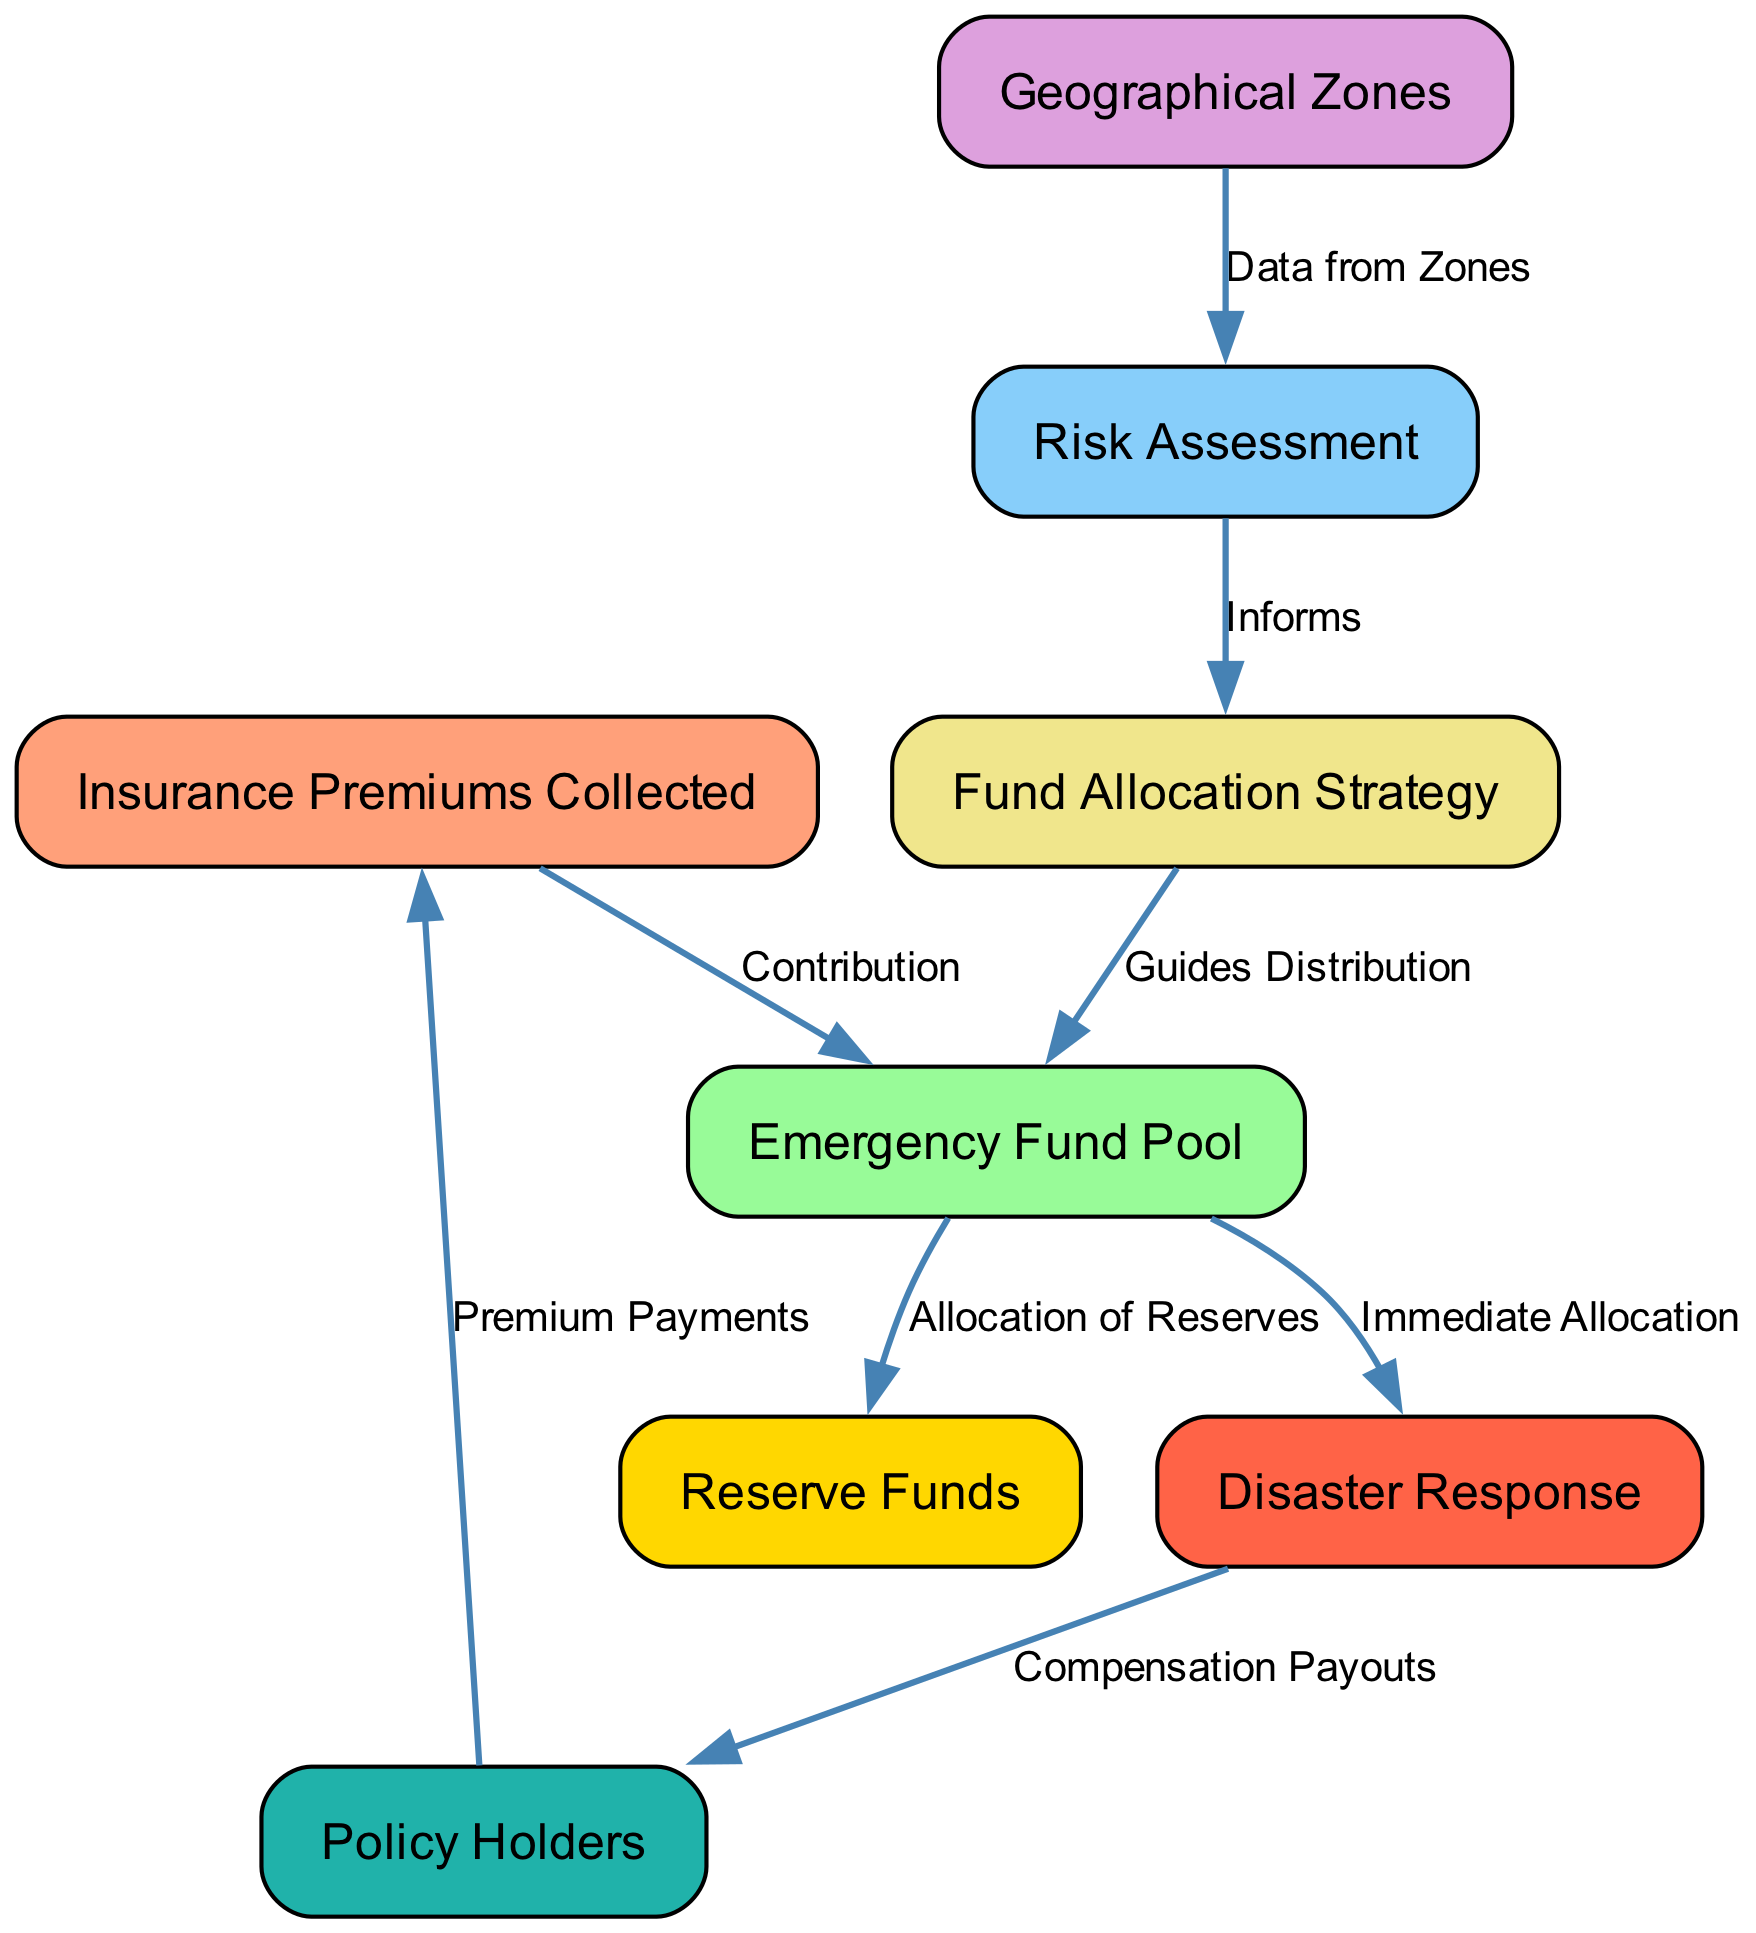What is the first node in the diagram? The first node is the starting point of the flow, which represents the collection of funds. According to the diagram, it is labeled "Insurance Premiums Collected."
Answer: Insurance Premiums Collected How many edges are there in the diagram? The edges in the diagram represent the relationships between the nodes. Counting them shows that there are a total of 8 edges connecting the different nodes.
Answer: 8 What node does the "Allocation of Reserves" edge connect to? The edge labeled "Allocation of Reserves" connects the "Emergency Fund Pool" to the "Reserve Funds." This indicates where the reserves are allocated from the emergency pool.
Answer: Reserve Funds Which node informs the "Fund Allocation Strategy"? The node that informs the "Fund Allocation Strategy" is "Risk Assessment." This node provides critical data necessary for devising effective strategies for fund allocation.
Answer: Risk Assessment What is the connection between "Policy Holders" and "Insurance Premiums Collected"? The connection between these two nodes is labeled as "Premium Payments," indicating that policy holders contribute to the insurance premiums collected by the company.
Answer: Premium Payments What is the purpose of the "Emergency Fund Pool" in relation to disaster response? The "Emergency Fund Pool" is designed to provide immediate allocation of funds specifically for disaster response efforts, illustrating its critical role in facilitating rapid financial support during emergencies.
Answer: Immediate Allocation Which node receives guidance from the "Fund Allocation Strategy"? The node receiving guidance from the "Fund Allocation Strategy" is the "Emergency Fund Pool." This shows that the strategy shapes how the funds will be distributed within the pool for various needs.
Answer: Emergency Fund Pool From which node does the data for "Risk Assessment" come? The data for "Risk Assessment" comes from the "Geographical Zones" node. This illustrates that assessments are based on information collected from different geographical areas.
Answer: Geographical Zones What is the outcome of the "Disaster Response" node for "Policy Holders"? The outcome for "Policy Holders" from the "Disaster Response" node is labeled as "Compensation Payouts," indicating that compensation is provided to policy holders following disaster events.
Answer: Compensation Payouts 